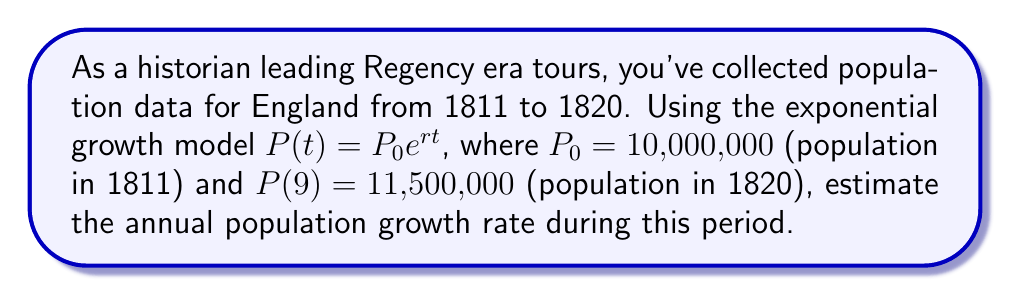Can you answer this question? 1. We use the exponential growth model: $P(t) = P_0e^{rt}$

2. Given:
   $P_0 = 10,000,000$ (initial population in 1811)
   $P(9) = 11,500,000$ (population after 9 years, in 1820)
   $t = 9$ years

3. Substitute the values into the equation:
   $11,500,000 = 10,000,000e^{9r}$

4. Divide both sides by 10,000,000:
   $1.15 = e^{9r}$

5. Take the natural logarithm of both sides:
   $\ln(1.15) = 9r$

6. Solve for $r$:
   $r = \frac{\ln(1.15)}{9}$

7. Calculate $r$:
   $r = \frac{0.139762}{9} \approx 0.0155291$

8. Convert to percentage:
   $0.0155291 \times 100\% \approx 1.55\%$
Answer: 1.55% per year 